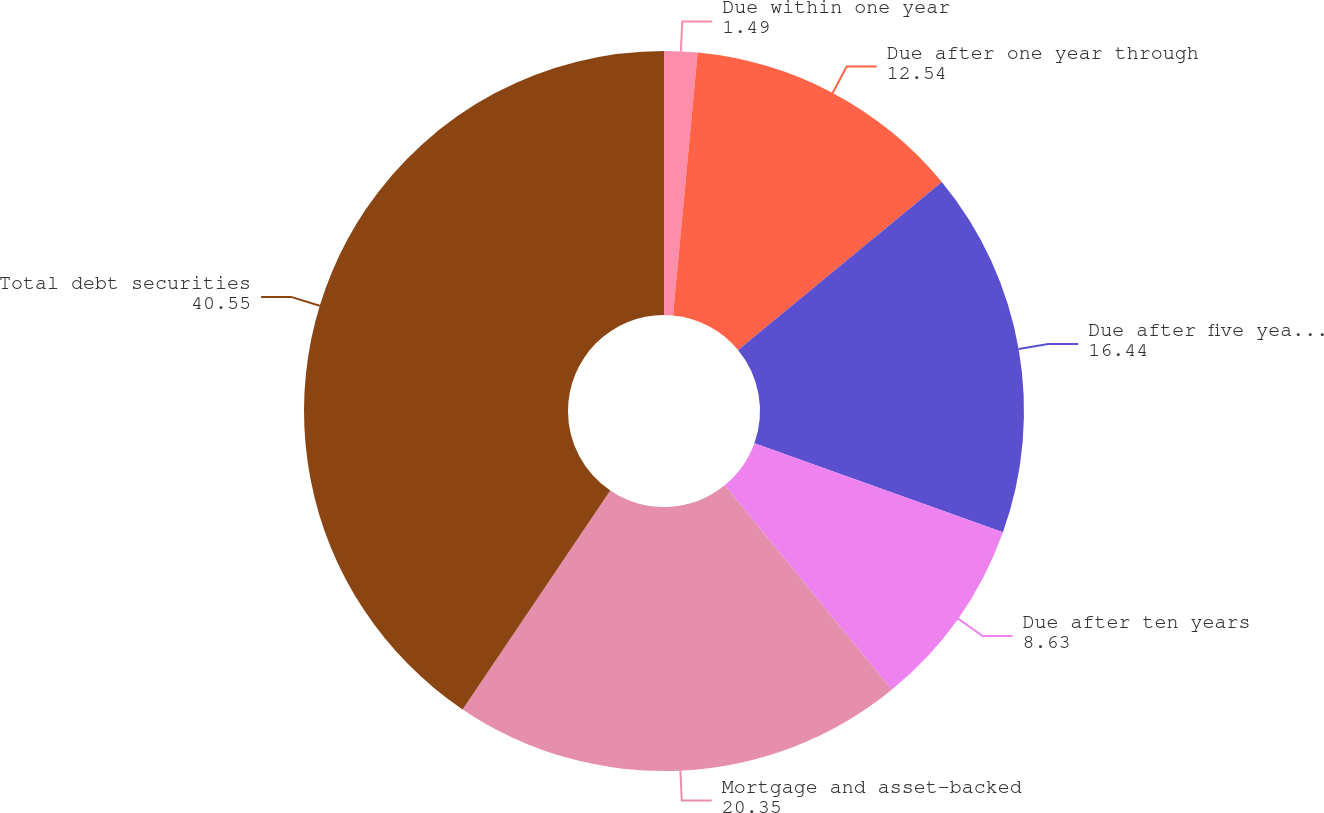Convert chart. <chart><loc_0><loc_0><loc_500><loc_500><pie_chart><fcel>Due within one year<fcel>Due after one year through<fcel>Due after five years through<fcel>Due after ten years<fcel>Mortgage and asset-backed<fcel>Total debt securities<nl><fcel>1.49%<fcel>12.54%<fcel>16.44%<fcel>8.63%<fcel>20.35%<fcel>40.55%<nl></chart> 